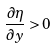<formula> <loc_0><loc_0><loc_500><loc_500>\frac { \partial \eta } { \partial y } > 0</formula> 